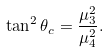<formula> <loc_0><loc_0><loc_500><loc_500>\tan ^ { 2 } \theta _ { c } = \frac { \mu _ { 3 } ^ { 2 } } { \mu _ { 4 } ^ { 2 } } .</formula> 